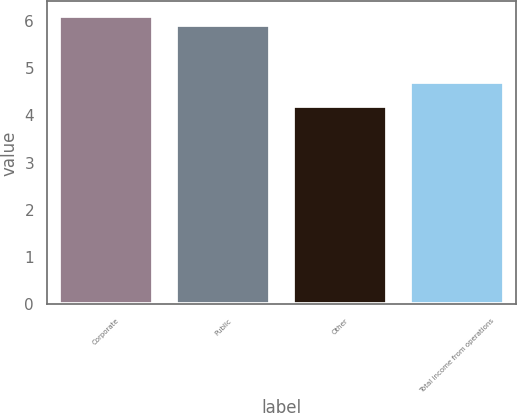Convert chart to OTSL. <chart><loc_0><loc_0><loc_500><loc_500><bar_chart><fcel>Corporate<fcel>Public<fcel>Other<fcel>Total income from operations<nl><fcel>6.1<fcel>5.9<fcel>4.2<fcel>4.7<nl></chart> 